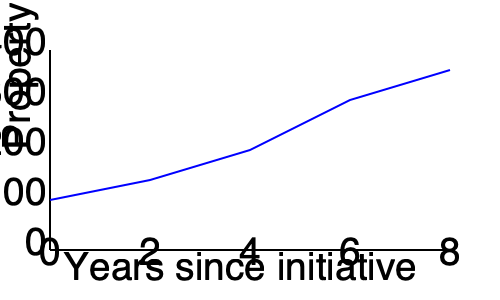Based on the line graph showing property values over time after implementing affordable housing initiatives, calculate the average annual increase in property value (in thousands of dollars) between years 2 and 6. To calculate the average annual increase in property value between years 2 and 6:

1. Identify property values:
   Year 2: $180,000
   Year 6: $300,000

2. Calculate total increase:
   $300,000 - $180,000 = $120,000

3. Determine time period:
   6 years - 2 years = 4 years

4. Calculate average annual increase:
   $120,000 ÷ 4 years = $30,000 per year

5. Convert to thousands of dollars:
   $30,000 ÷ $1,000 = 30

Therefore, the average annual increase in property value between years 2 and 6 is $30,000 or 30 thousand dollars.
Answer: 30 